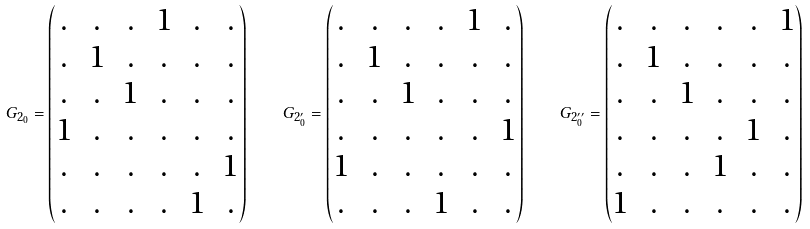Convert formula to latex. <formula><loc_0><loc_0><loc_500><loc_500>G _ { 2 _ { 0 } } = \begin{pmatrix} . & . & . & 1 & . & . \\ . & 1 & . & . & . & . \\ . & . & 1 & . & . & . \\ 1 & . & . & . & . & . \\ . & . & . & . & . & 1 \\ . & . & . & . & 1 & . \end{pmatrix} \quad G _ { 2 _ { 0 } ^ { \prime } } = \begin{pmatrix} . & . & . & . & 1 & . \\ . & 1 & . & . & . & . \\ . & . & 1 & . & . & . \\ . & . & . & . & . & 1 \\ 1 & . & . & . & . & . \\ . & . & . & 1 & . & . \end{pmatrix} \quad G _ { 2 _ { 0 } ^ { \prime \prime } } = \begin{pmatrix} . & . & . & . & . & 1 \\ . & 1 & . & . & . & . \\ . & . & 1 & . & . & . \\ . & . & . & . & 1 & . \\ . & . & . & 1 & . & . \\ 1 & . & . & . & . & . \end{pmatrix}</formula> 